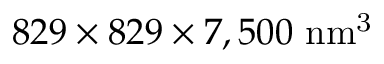<formula> <loc_0><loc_0><loc_500><loc_500>8 2 9 \times 8 2 9 \times 7 , 5 0 0 \ { n m ^ { 3 } }</formula> 